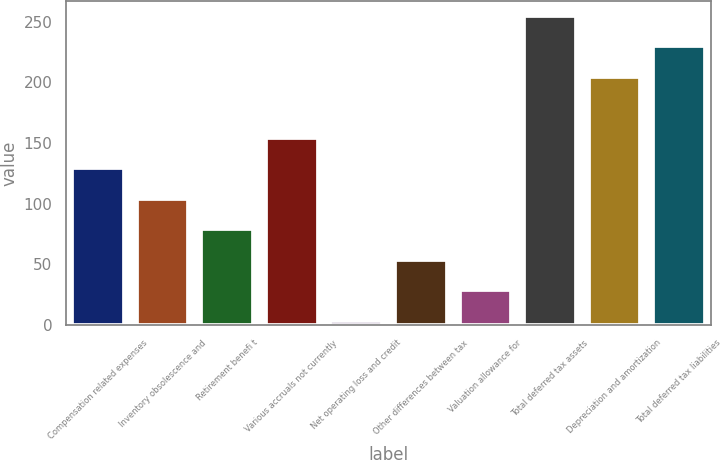Convert chart to OTSL. <chart><loc_0><loc_0><loc_500><loc_500><bar_chart><fcel>Compensation related expenses<fcel>Inventory obsolescence and<fcel>Retirement benefi t<fcel>Various accruals not currently<fcel>Net operating loss and credit<fcel>Other differences between tax<fcel>Valuation allowance for<fcel>Total deferred tax assets<fcel>Depreciation and amortization<fcel>Total deferred tax liabilities<nl><fcel>129.1<fcel>103.96<fcel>78.82<fcel>154.24<fcel>3.4<fcel>53.68<fcel>28.54<fcel>254.8<fcel>204.52<fcel>229.66<nl></chart> 